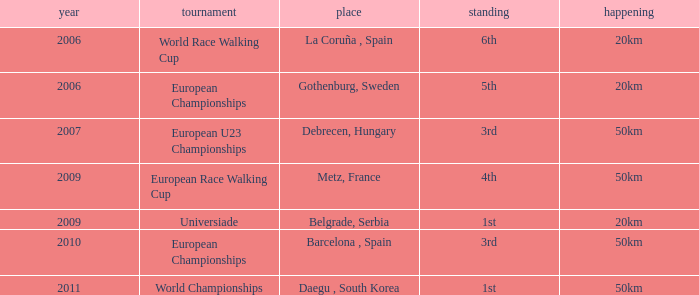What is the Position for the European U23 Championships? 3rd. 